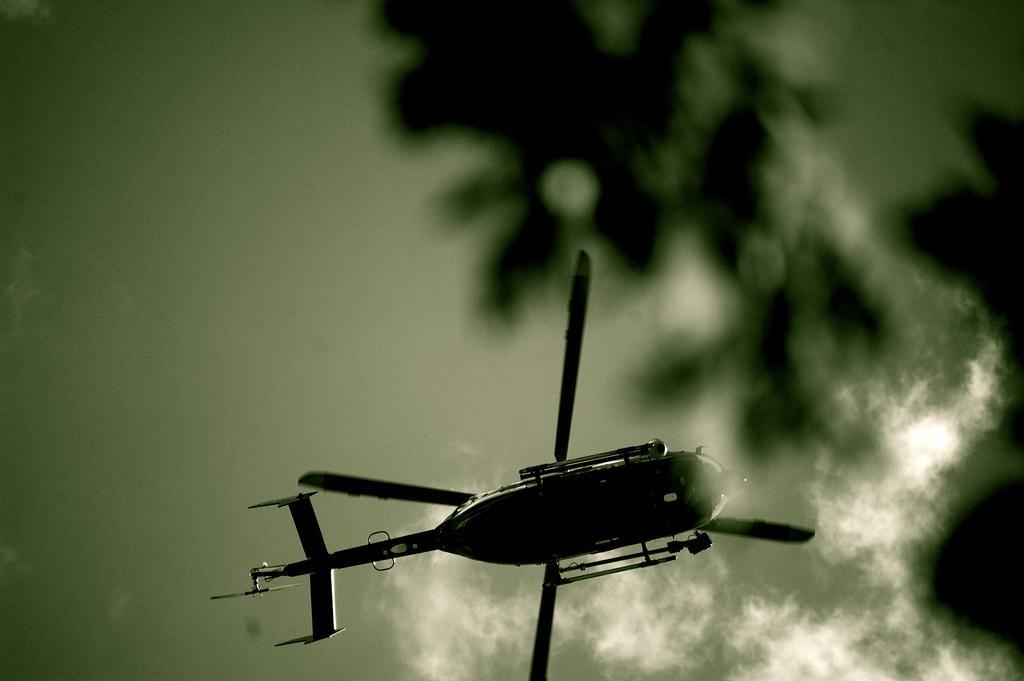Describe this image in one or two sentences. There is a helicopter flying. In the background there is sky with clouds. 